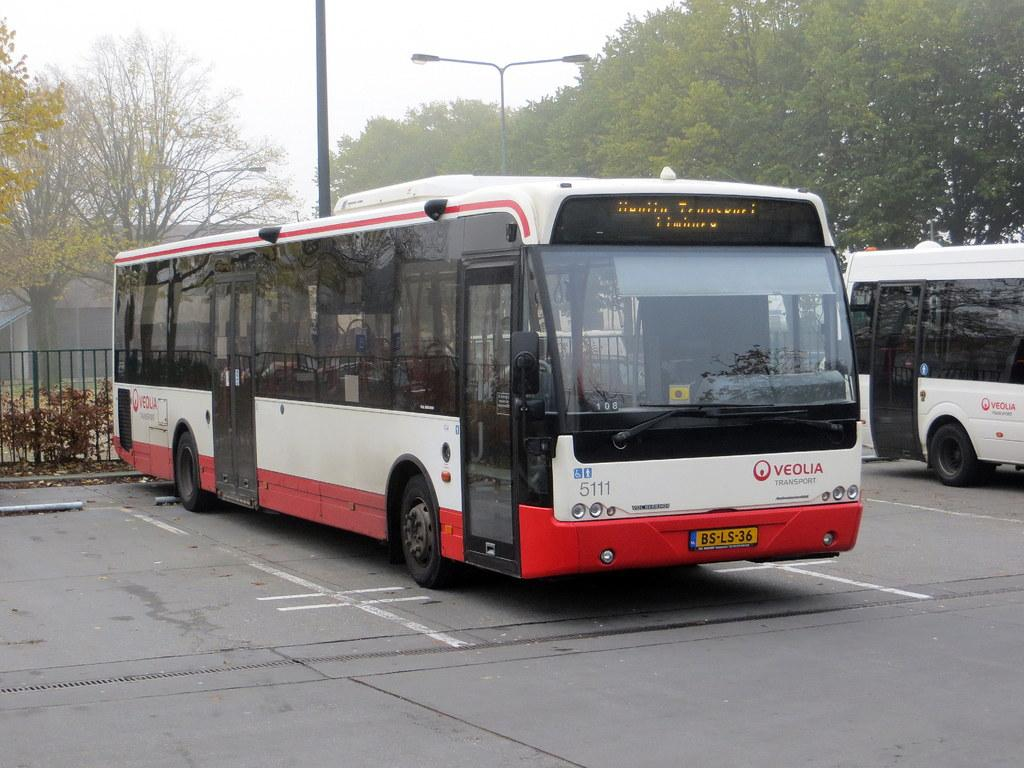<image>
Describe the image concisely. A bus that is white, red and black with Veola Transport written on it. 